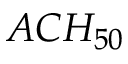Convert formula to latex. <formula><loc_0><loc_0><loc_500><loc_500>A C H _ { 5 0 } \,</formula> 